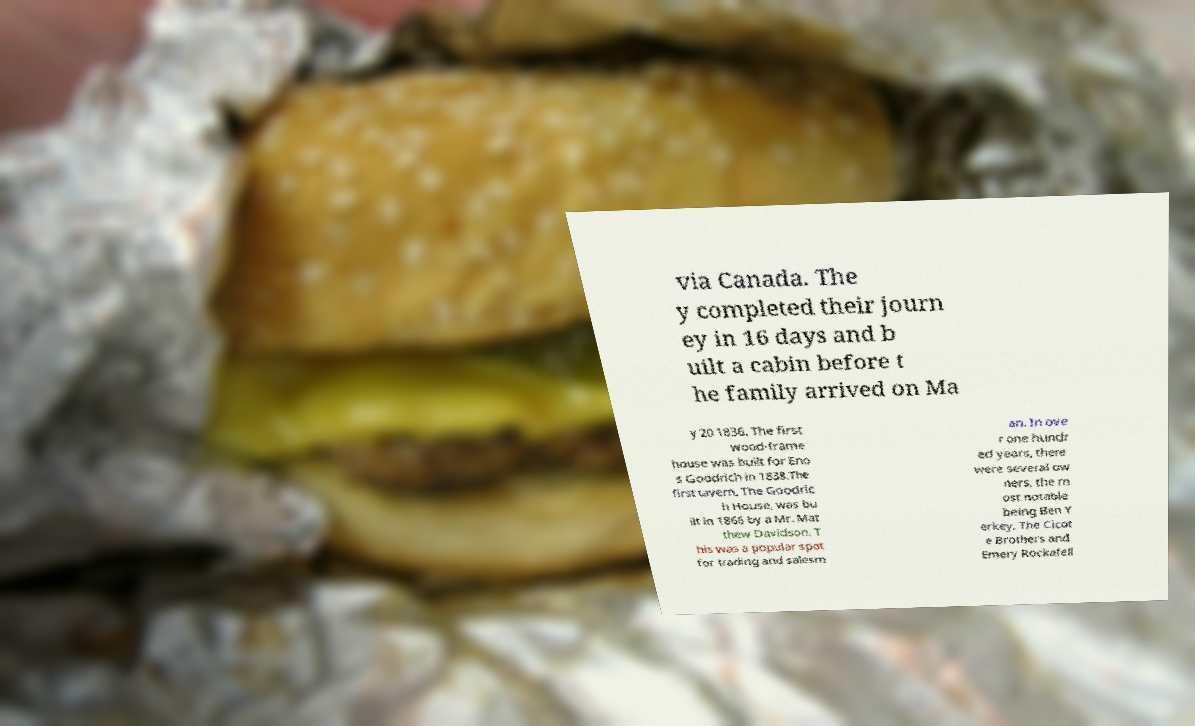Could you assist in decoding the text presented in this image and type it out clearly? via Canada. The y completed their journ ey in 16 days and b uilt a cabin before t he family arrived on Ma y 20 1836. The first wood-frame house was built for Eno s Goodrich in 1838.The first tavern, The Goodric h House, was bu ilt in 1866 by a Mr. Mat thew Davidson. T his was a popular spot for trading and salesm an. In ove r one hundr ed years, there were several ow ners, the m ost notable being Ben Y erkey, The Cicot e Brothers and Emery Rockafell 